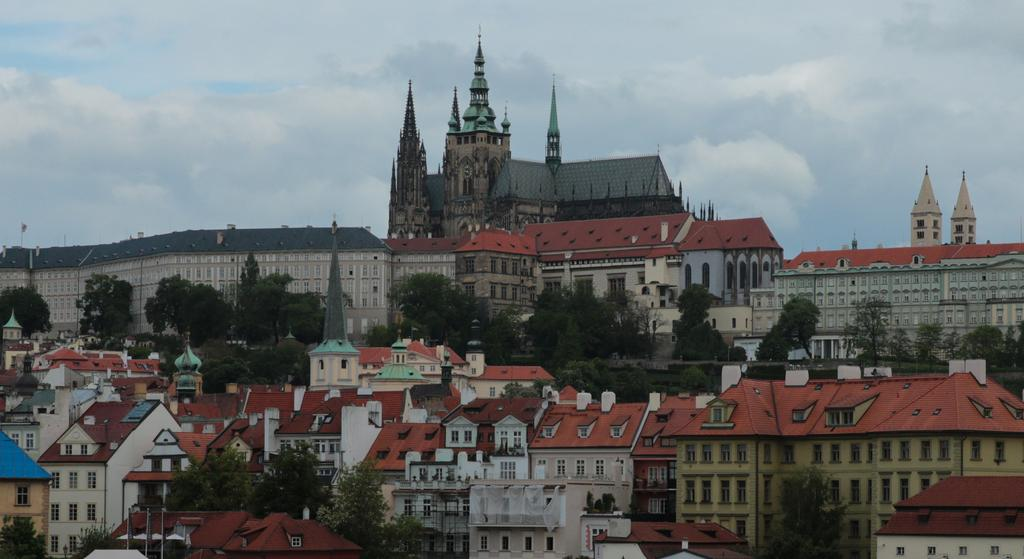What type of natural elements can be seen in the image? There are trees in the image. What type of man-made structures are present in the image? There are buildings with windows in the image. Can you describe any other objects in the image? There are some objects in the image. What is visible in the background of the image? The sky is visible in the background of the image. What can be seen in the sky? Clouds are present in the sky. What type of knowledge is being shared in the image? There is no indication of knowledge being shared in the image. Can you tell me which hospital is depicted in the image? There is no hospital present in the image. 